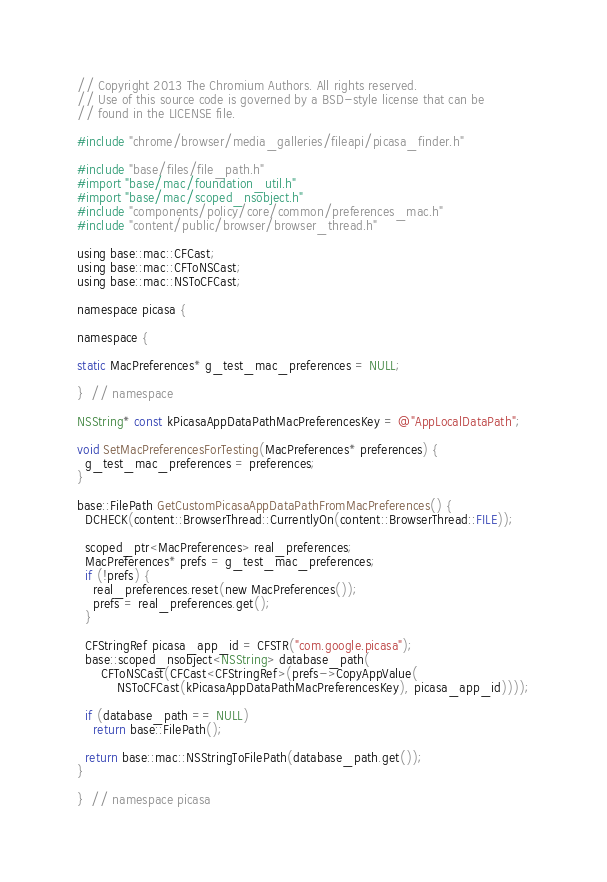<code> <loc_0><loc_0><loc_500><loc_500><_ObjectiveC_>// Copyright 2013 The Chromium Authors. All rights reserved.
// Use of this source code is governed by a BSD-style license that can be
// found in the LICENSE file.

#include "chrome/browser/media_galleries/fileapi/picasa_finder.h"

#include "base/files/file_path.h"
#import "base/mac/foundation_util.h"
#import "base/mac/scoped_nsobject.h"
#include "components/policy/core/common/preferences_mac.h"
#include "content/public/browser/browser_thread.h"

using base::mac::CFCast;
using base::mac::CFToNSCast;
using base::mac::NSToCFCast;

namespace picasa {

namespace {

static MacPreferences* g_test_mac_preferences = NULL;

}  // namespace

NSString* const kPicasaAppDataPathMacPreferencesKey = @"AppLocalDataPath";

void SetMacPreferencesForTesting(MacPreferences* preferences) {
  g_test_mac_preferences = preferences;
}

base::FilePath GetCustomPicasaAppDataPathFromMacPreferences() {
  DCHECK(content::BrowserThread::CurrentlyOn(content::BrowserThread::FILE));

  scoped_ptr<MacPreferences> real_preferences;
  MacPreferences* prefs = g_test_mac_preferences;
  if (!prefs) {
    real_preferences.reset(new MacPreferences());
    prefs = real_preferences.get();
  }

  CFStringRef picasa_app_id = CFSTR("com.google.picasa");
  base::scoped_nsobject<NSString> database_path(
      CFToNSCast(CFCast<CFStringRef>(prefs->CopyAppValue(
          NSToCFCast(kPicasaAppDataPathMacPreferencesKey), picasa_app_id))));

  if (database_path == NULL)
    return base::FilePath();

  return base::mac::NSStringToFilePath(database_path.get());
}

}  // namespace picasa
</code> 